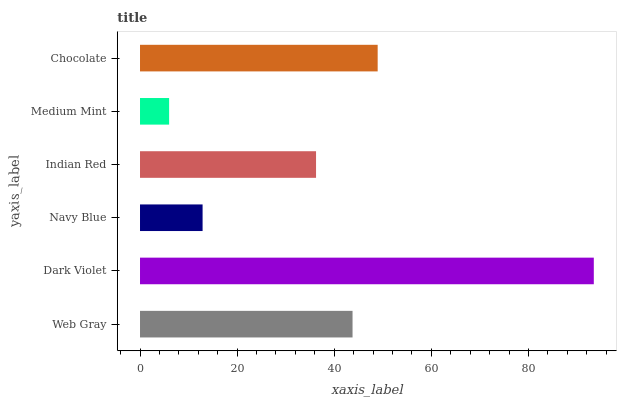Is Medium Mint the minimum?
Answer yes or no. Yes. Is Dark Violet the maximum?
Answer yes or no. Yes. Is Navy Blue the minimum?
Answer yes or no. No. Is Navy Blue the maximum?
Answer yes or no. No. Is Dark Violet greater than Navy Blue?
Answer yes or no. Yes. Is Navy Blue less than Dark Violet?
Answer yes or no. Yes. Is Navy Blue greater than Dark Violet?
Answer yes or no. No. Is Dark Violet less than Navy Blue?
Answer yes or no. No. Is Web Gray the high median?
Answer yes or no. Yes. Is Indian Red the low median?
Answer yes or no. Yes. Is Navy Blue the high median?
Answer yes or no. No. Is Web Gray the low median?
Answer yes or no. No. 